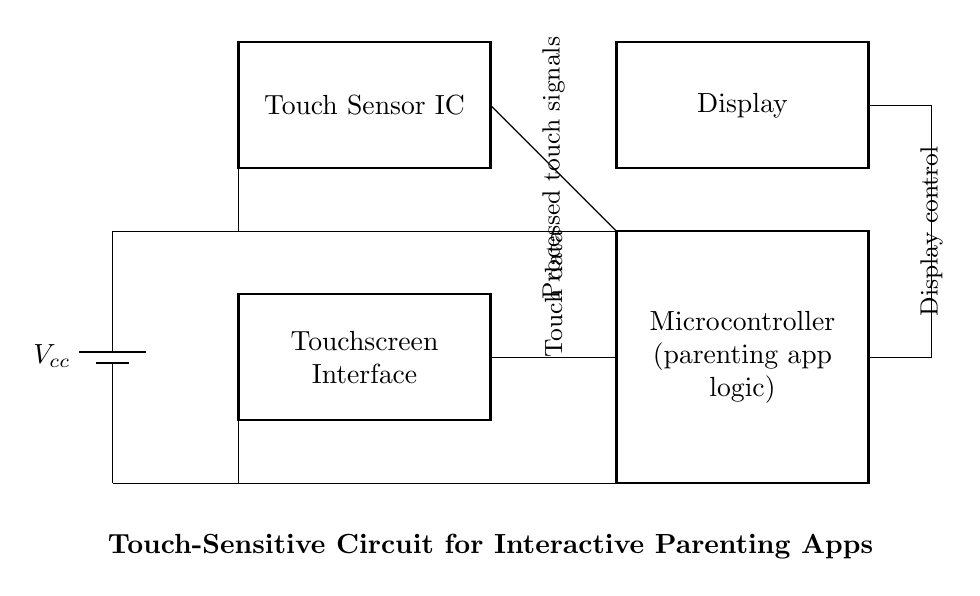What is the main function of the microcontroller? The microcontroller is tasked with processing the logic for the parenting app, handling user interactions via the touchscreen, and controlling the display based on input signals.
Answer: Parenting app logic What component detects touch input? The touch sensor integrated circuit (IC) is responsible for sensing touch on the touchscreen area and sending those signals to the microcontroller for further processing.
Answer: Touch Sensor IC How many main components are in this circuit? There are four main components: the battery, touchscreen interface, microcontroller, and display.
Answer: Four What type of circuit is depicted in the diagram? This circuit is a touch-sensitive interactive device specific for parenting apps and conflict resolution games, integrating user interaction through touch.
Answer: Touch-sensitive circuit What is the power supply voltage labeled as? The power supply voltage is labeled as Vcc, indicating the voltage source for the entire circuit, supplying power to the components.
Answer: Vcc What is the purpose of the display in this circuit? The display serves to present information and feedback to the users based on interactions they have with the parenting app, facilitating a user-friendly experience.
Answer: Display What do the connections labeled as "Ground" represent? The ground connections in the circuit provide a common return path for electrical current and help stabilize the circuit by connecting all components to a reference voltage level.
Answer: Common return path 